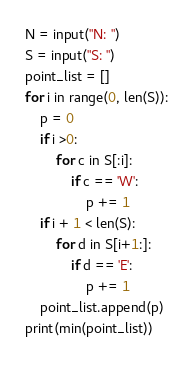Convert code to text. <code><loc_0><loc_0><loc_500><loc_500><_Python_>N = input("N: ")
S = input("S: ")
point_list = []
for i in range(0, len(S)):
	p = 0
	if i >0:
		for c in S[:i]:
			if c == 'W':
				p += 1
	if i + 1 < len(S):
		for d in S[i+1:]:
			if d == 'E':
				p += 1
	point_list.append(p)
print(min(point_list))</code> 